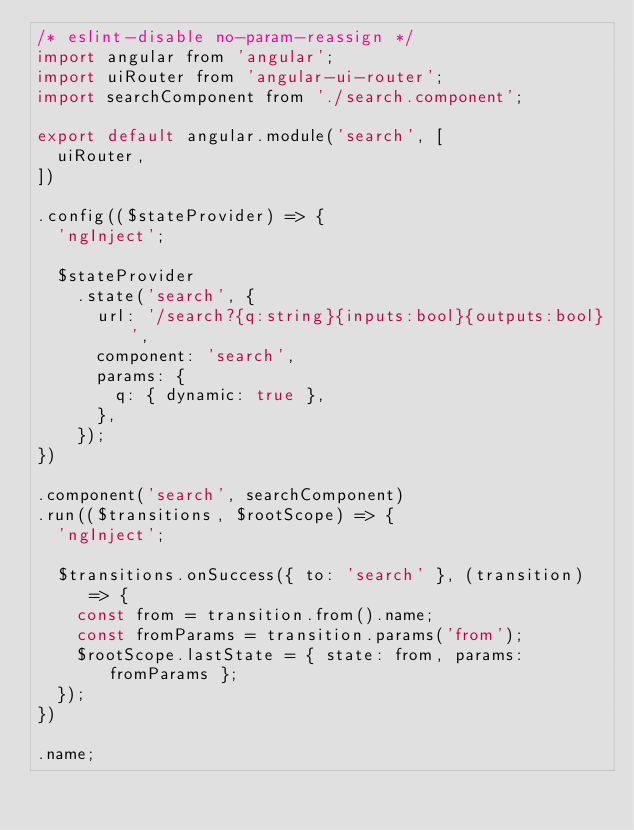<code> <loc_0><loc_0><loc_500><loc_500><_JavaScript_>/* eslint-disable no-param-reassign */
import angular from 'angular';
import uiRouter from 'angular-ui-router';
import searchComponent from './search.component';

export default angular.module('search', [
  uiRouter,
])

.config(($stateProvider) => {
  'ngInject';

  $stateProvider
    .state('search', {
      url: '/search?{q:string}{inputs:bool}{outputs:bool}',
      component: 'search',
      params: {
        q: { dynamic: true },
      },
    });
})

.component('search', searchComponent)
.run(($transitions, $rootScope) => {
  'ngInject';

  $transitions.onSuccess({ to: 'search' }, (transition) => {
    const from = transition.from().name;
    const fromParams = transition.params('from');
    $rootScope.lastState = { state: from, params: fromParams };
  });
})

.name;
</code> 